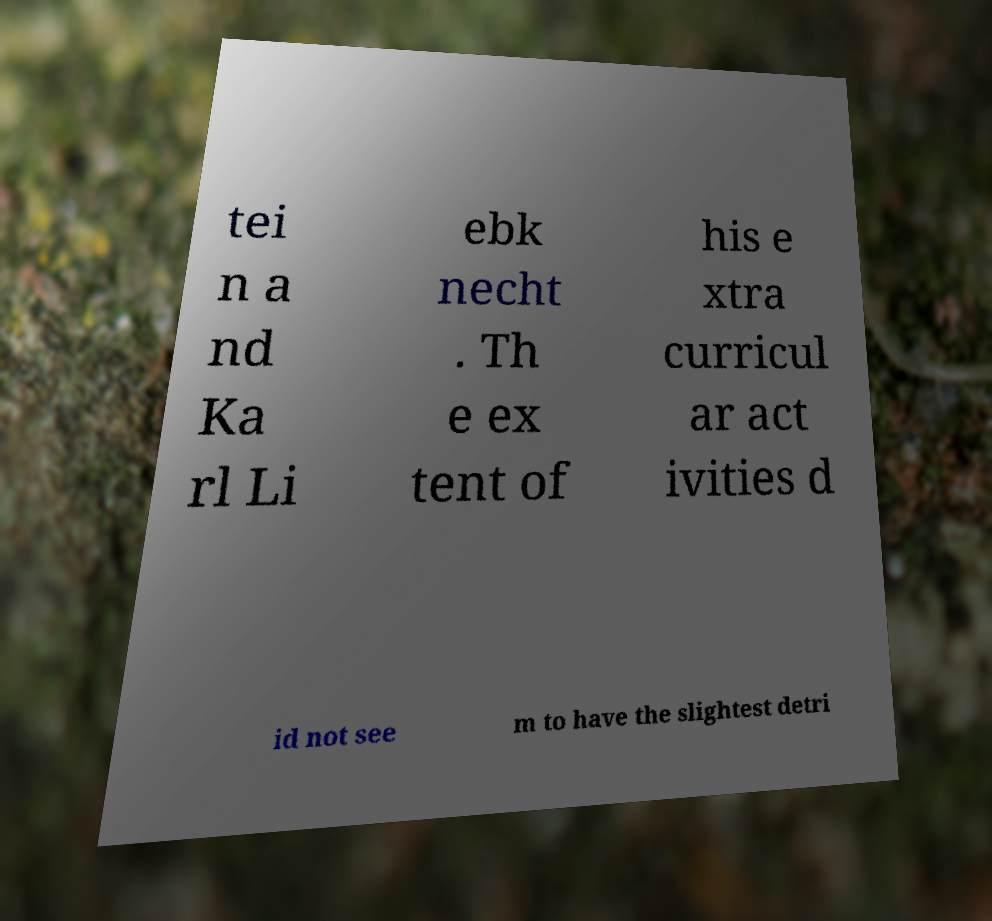I need the written content from this picture converted into text. Can you do that? tei n a nd Ka rl Li ebk necht . Th e ex tent of his e xtra curricul ar act ivities d id not see m to have the slightest detri 